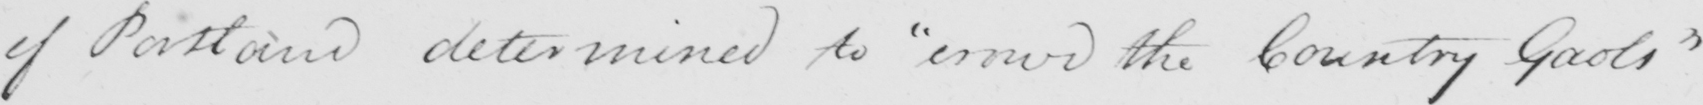Please provide the text content of this handwritten line. of Portland determined to  " crowd the County Gaols " 